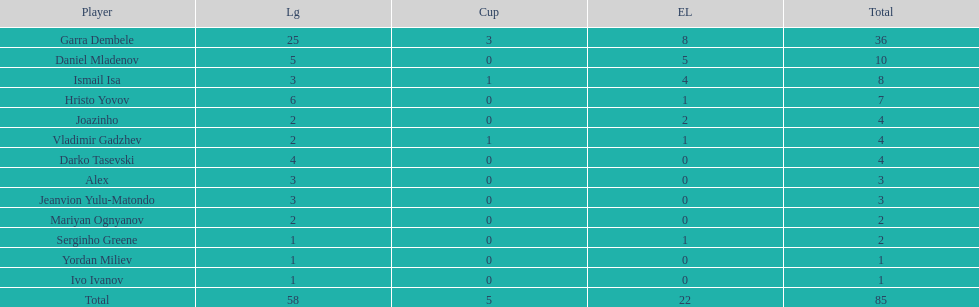Which player is in the same league as joazinho and vladimir gadzhev? Mariyan Ognyanov. 